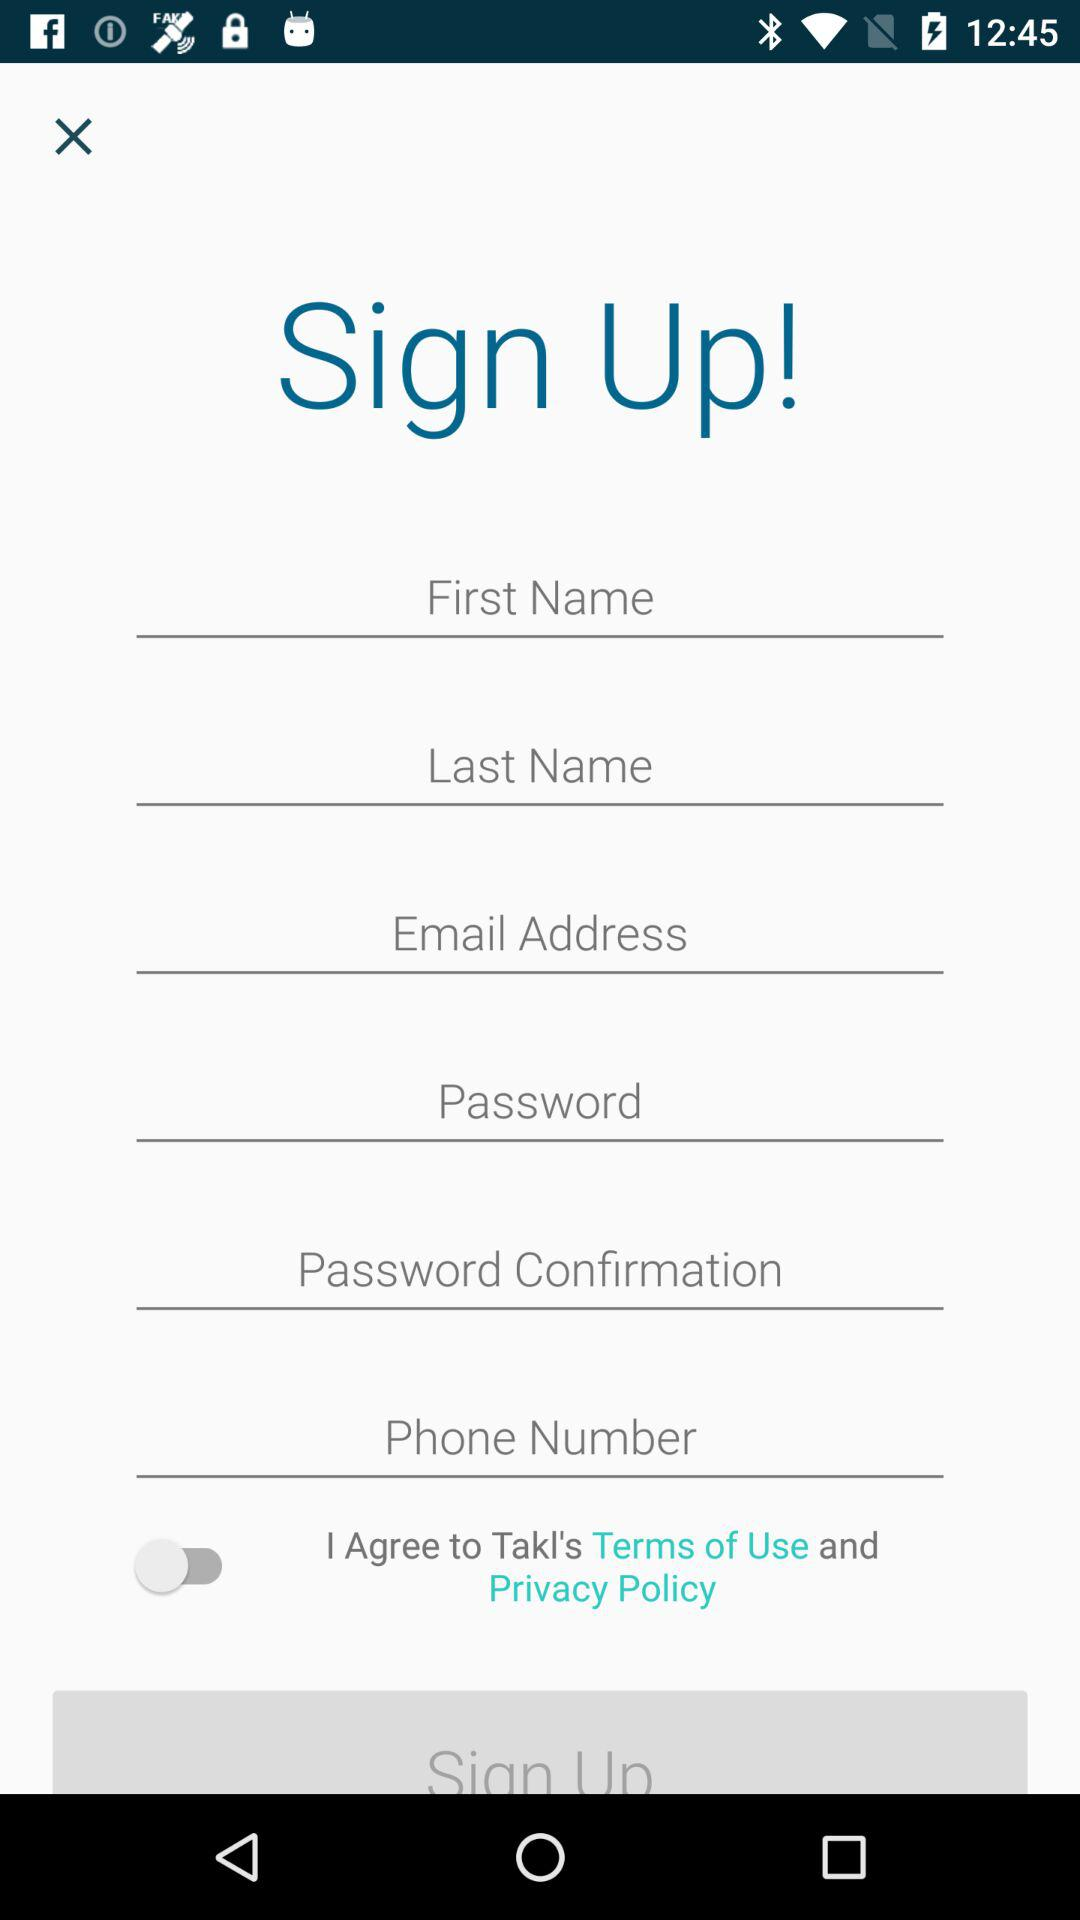What is the status of the option that includes agreement to the “Terms of Use” and “Privacy Policy”? The status is "off". 